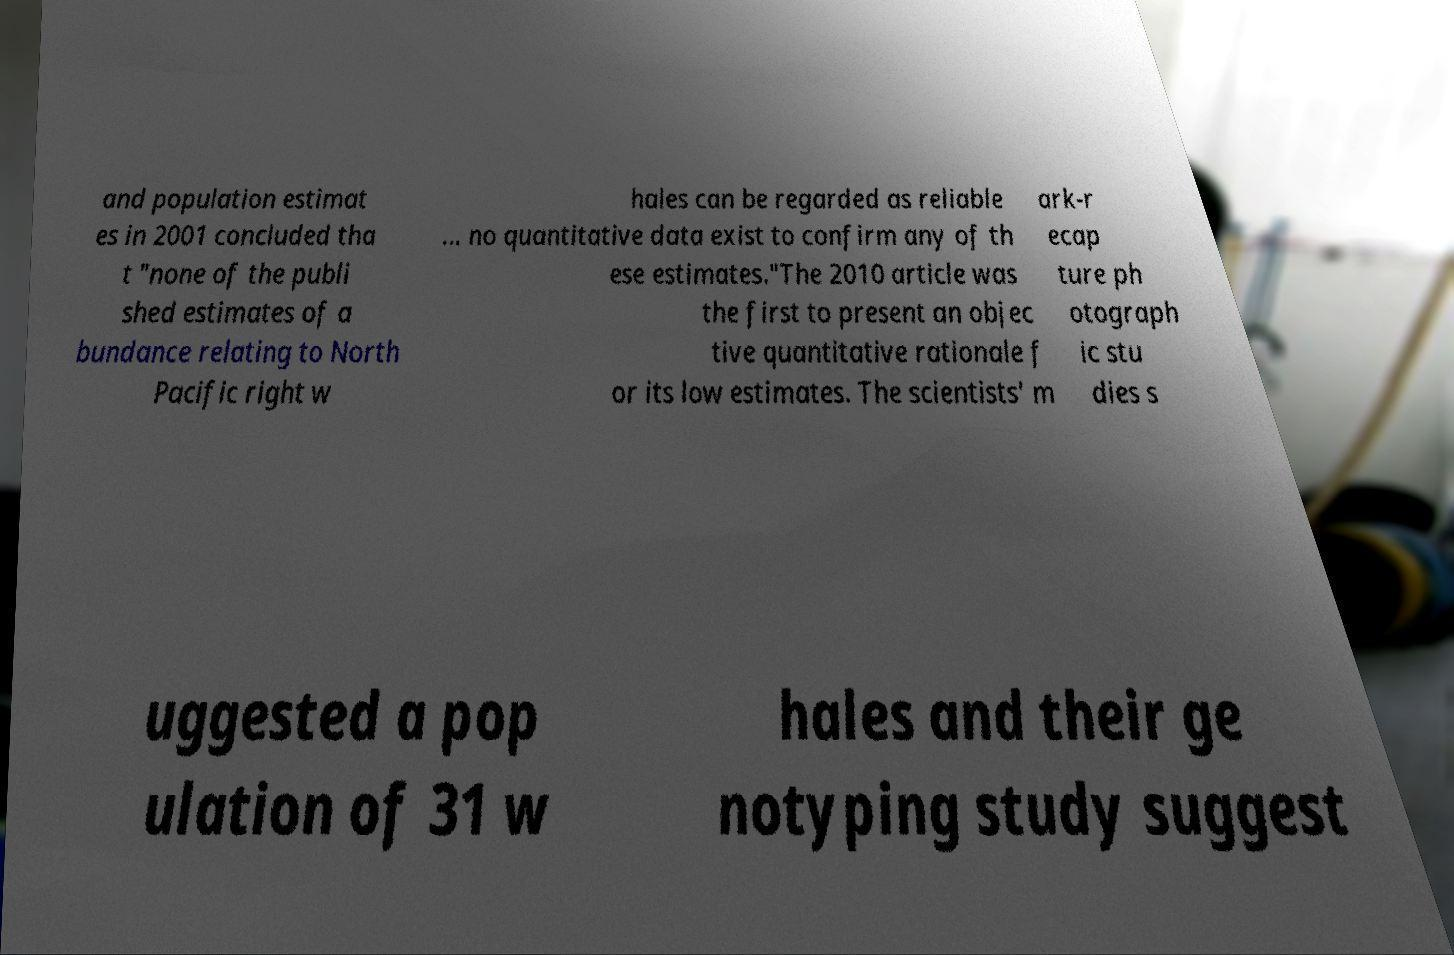There's text embedded in this image that I need extracted. Can you transcribe it verbatim? and population estimat es in 2001 concluded tha t "none of the publi shed estimates of a bundance relating to North Pacific right w hales can be regarded as reliable ... no quantitative data exist to confirm any of th ese estimates."The 2010 article was the first to present an objec tive quantitative rationale f or its low estimates. The scientists' m ark-r ecap ture ph otograph ic stu dies s uggested a pop ulation of 31 w hales and their ge notyping study suggest 